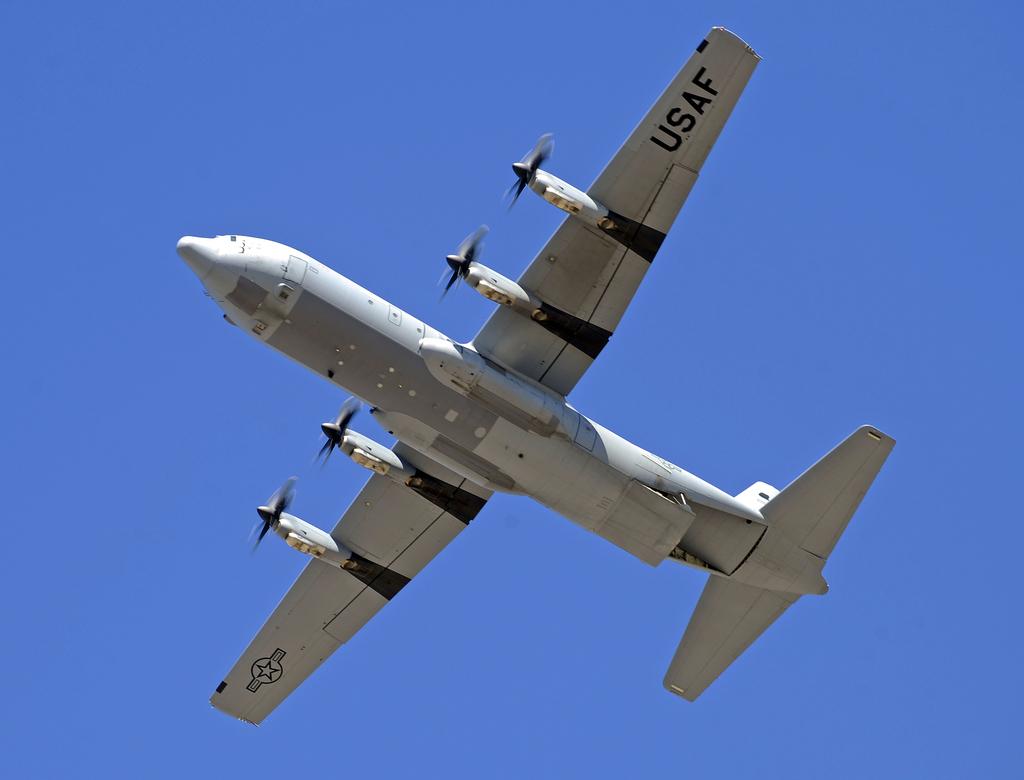What is the plane's call sign?
Your answer should be compact. Usaf. 